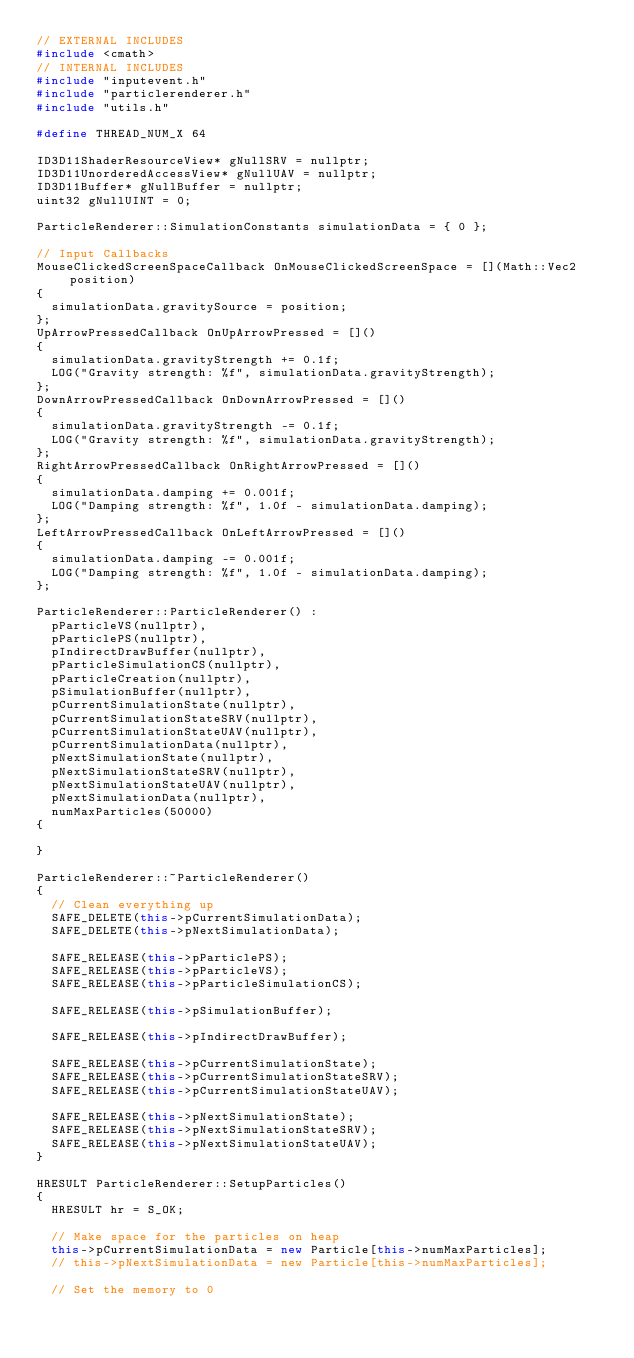<code> <loc_0><loc_0><loc_500><loc_500><_C++_>// EXTERNAL INCLUDES
#include <cmath>
// INTERNAL INCLUDES
#include "inputevent.h"
#include "particlerenderer.h"
#include "utils.h"

#define THREAD_NUM_X 64

ID3D11ShaderResourceView* gNullSRV = nullptr;
ID3D11UnorderedAccessView* gNullUAV = nullptr;
ID3D11Buffer* gNullBuffer = nullptr;
uint32 gNullUINT = 0;

ParticleRenderer::SimulationConstants simulationData = { 0 };

// Input Callbacks
MouseClickedScreenSpaceCallback OnMouseClickedScreenSpace = [](Math::Vec2 position)
{
	simulationData.gravitySource = position;
};
UpArrowPressedCallback OnUpArrowPressed = []()
{
	simulationData.gravityStrength += 0.1f;
	LOG("Gravity strength: %f", simulationData.gravityStrength);
};
DownArrowPressedCallback OnDownArrowPressed = []()
{
	simulationData.gravityStrength -= 0.1f;
	LOG("Gravity strength: %f", simulationData.gravityStrength);
};
RightArrowPressedCallback OnRightArrowPressed = []()
{
	simulationData.damping += 0.001f;
	LOG("Damping strength: %f", 1.0f - simulationData.damping);
};
LeftArrowPressedCallback OnLeftArrowPressed = []()
{
	simulationData.damping -= 0.001f;
	LOG("Damping strength: %f", 1.0f - simulationData.damping);
};

ParticleRenderer::ParticleRenderer() :
	pParticleVS(nullptr),
	pParticlePS(nullptr),
	pIndirectDrawBuffer(nullptr),
	pParticleSimulationCS(nullptr),
	pParticleCreation(nullptr),
	pSimulationBuffer(nullptr),
	pCurrentSimulationState(nullptr),
	pCurrentSimulationStateSRV(nullptr),
	pCurrentSimulationStateUAV(nullptr),
	pCurrentSimulationData(nullptr),
	pNextSimulationState(nullptr),
	pNextSimulationStateSRV(nullptr),
	pNextSimulationStateUAV(nullptr),
	pNextSimulationData(nullptr),
	numMaxParticles(50000)
{

}

ParticleRenderer::~ParticleRenderer()
{
	// Clean everything up
	SAFE_DELETE(this->pCurrentSimulationData);
	SAFE_DELETE(this->pNextSimulationData);

	SAFE_RELEASE(this->pParticlePS);
	SAFE_RELEASE(this->pParticleVS);
	SAFE_RELEASE(this->pParticleSimulationCS);

	SAFE_RELEASE(this->pSimulationBuffer);

	SAFE_RELEASE(this->pIndirectDrawBuffer);

	SAFE_RELEASE(this->pCurrentSimulationState);
	SAFE_RELEASE(this->pCurrentSimulationStateSRV);
	SAFE_RELEASE(this->pCurrentSimulationStateUAV);

	SAFE_RELEASE(this->pNextSimulationState);
	SAFE_RELEASE(this->pNextSimulationStateSRV);
	SAFE_RELEASE(this->pNextSimulationStateUAV);
}

HRESULT ParticleRenderer::SetupParticles()
{
	HRESULT hr = S_OK;

	// Make space for the particles on heap
	this->pCurrentSimulationData = new Particle[this->numMaxParticles];
	// this->pNextSimulationData = new Particle[this->numMaxParticles];

	// Set the memory to 0</code> 